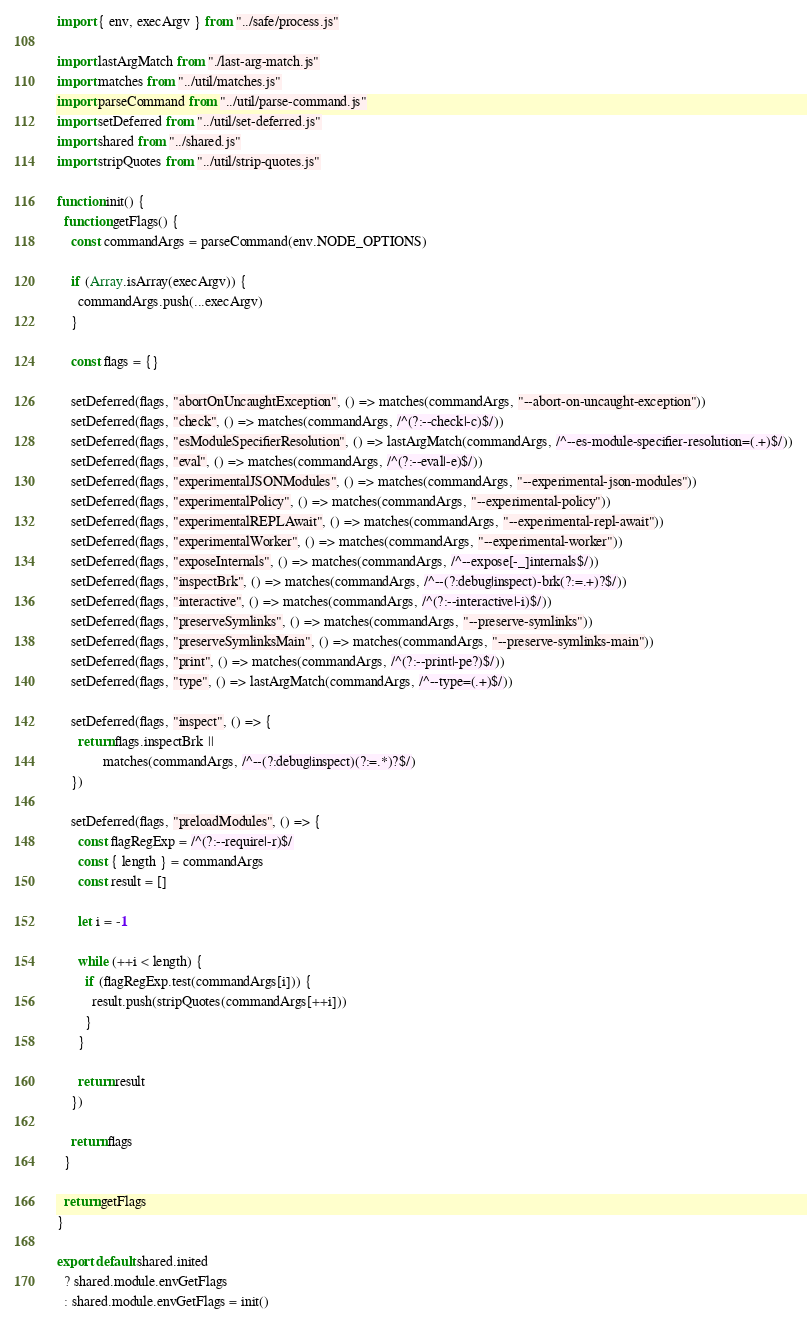<code> <loc_0><loc_0><loc_500><loc_500><_JavaScript_>import { env, execArgv } from "../safe/process.js"

import lastArgMatch from "./last-arg-match.js"
import matches from "../util/matches.js"
import parseCommand from "../util/parse-command.js"
import setDeferred from "../util/set-deferred.js"
import shared from "../shared.js"
import stripQuotes from "../util/strip-quotes.js"

function init() {
  function getFlags() {
    const commandArgs = parseCommand(env.NODE_OPTIONS)

    if (Array.isArray(execArgv)) {
      commandArgs.push(...execArgv)
    }

    const flags = {}

    setDeferred(flags, "abortOnUncaughtException", () => matches(commandArgs, "--abort-on-uncaught-exception"))
    setDeferred(flags, "check", () => matches(commandArgs, /^(?:--check|-c)$/))
    setDeferred(flags, "esModuleSpecifierResolution", () => lastArgMatch(commandArgs, /^--es-module-specifier-resolution=(.+)$/))
    setDeferred(flags, "eval", () => matches(commandArgs, /^(?:--eval|-e)$/))
    setDeferred(flags, "experimentalJSONModules", () => matches(commandArgs, "--experimental-json-modules"))
    setDeferred(flags, "experimentalPolicy", () => matches(commandArgs, "--experimental-policy"))
    setDeferred(flags, "experimentalREPLAwait", () => matches(commandArgs, "--experimental-repl-await"))
    setDeferred(flags, "experimentalWorker", () => matches(commandArgs, "--experimental-worker"))
    setDeferred(flags, "exposeInternals", () => matches(commandArgs, /^--expose[-_]internals$/))
    setDeferred(flags, "inspectBrk", () => matches(commandArgs, /^--(?:debug|inspect)-brk(?:=.+)?$/))
    setDeferred(flags, "interactive", () => matches(commandArgs, /^(?:--interactive|-i)$/))
    setDeferred(flags, "preserveSymlinks", () => matches(commandArgs, "--preserve-symlinks"))
    setDeferred(flags, "preserveSymlinksMain", () => matches(commandArgs, "--preserve-symlinks-main"))
    setDeferred(flags, "print", () => matches(commandArgs, /^(?:--print|-pe?)$/))
    setDeferred(flags, "type", () => lastArgMatch(commandArgs, /^--type=(.+)$/))

    setDeferred(flags, "inspect", () => {
      return flags.inspectBrk ||
             matches(commandArgs, /^--(?:debug|inspect)(?:=.*)?$/)
    })

    setDeferred(flags, "preloadModules", () => {
      const flagRegExp = /^(?:--require|-r)$/
      const { length } = commandArgs
      const result = []

      let i = -1

      while (++i < length) {
        if (flagRegExp.test(commandArgs[i])) {
          result.push(stripQuotes(commandArgs[++i]))
        }
      }

      return result
    })

    return flags
  }

  return getFlags
}

export default shared.inited
  ? shared.module.envGetFlags
  : shared.module.envGetFlags = init()
</code> 